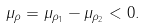<formula> <loc_0><loc_0><loc_500><loc_500>\mu _ { \rho } = \mu _ { \rho _ { 1 } } - \mu _ { \rho _ { 2 } } < 0 .</formula> 